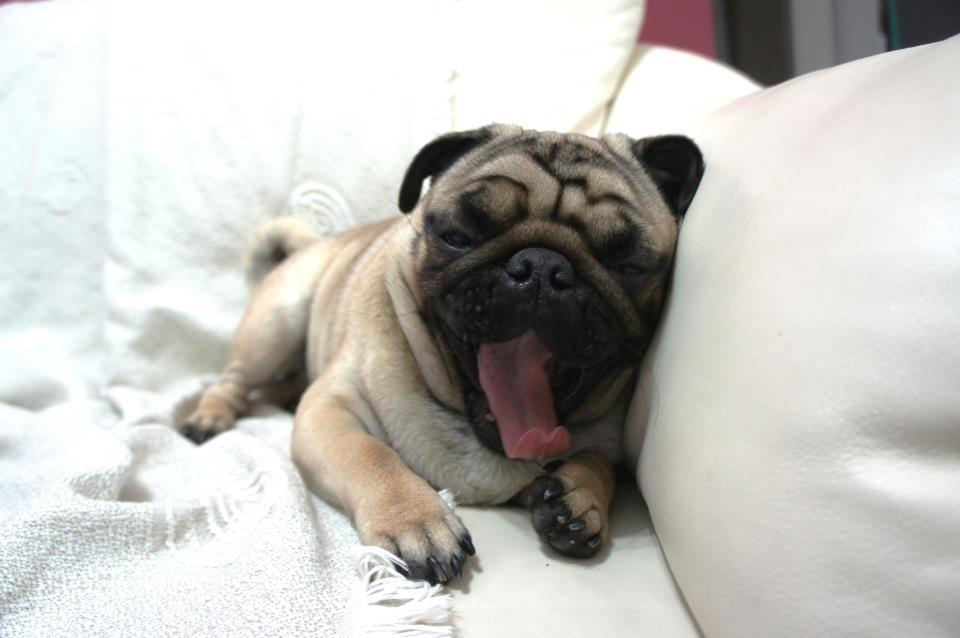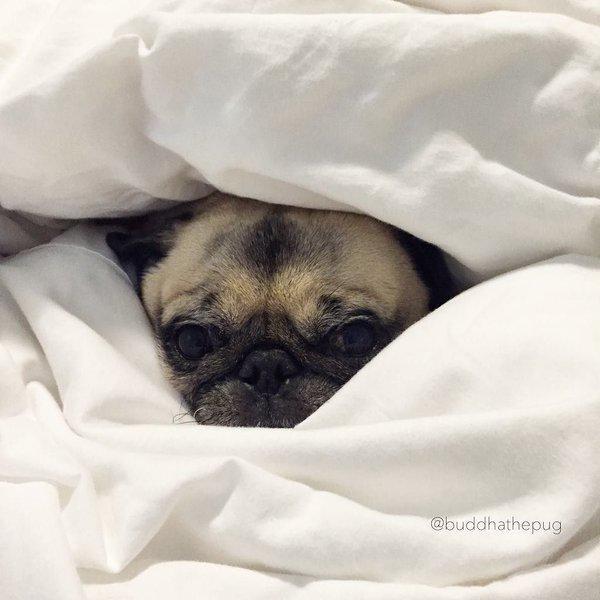The first image is the image on the left, the second image is the image on the right. Given the left and right images, does the statement "A black pug lying with its head sideways is peeking out from under a sheet in the left image." hold true? Answer yes or no. No. The first image is the image on the left, the second image is the image on the right. For the images shown, is this caption "In the right image, the pug has no paws sticking out of the blanket." true? Answer yes or no. Yes. 